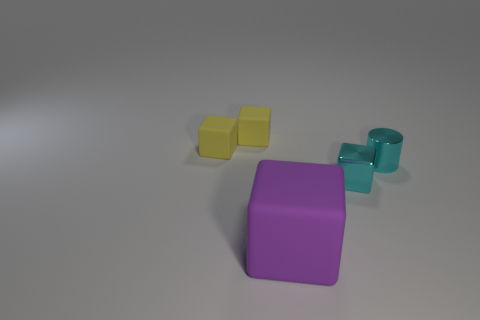Add 5 purple cubes. How many objects exist? 10 Subtract all cylinders. How many objects are left? 4 Add 5 tiny cyan cylinders. How many tiny cyan cylinders are left? 6 Add 2 purple matte objects. How many purple matte objects exist? 3 Subtract 1 cyan cylinders. How many objects are left? 4 Subtract all small metal cylinders. Subtract all tiny cyan metallic blocks. How many objects are left? 3 